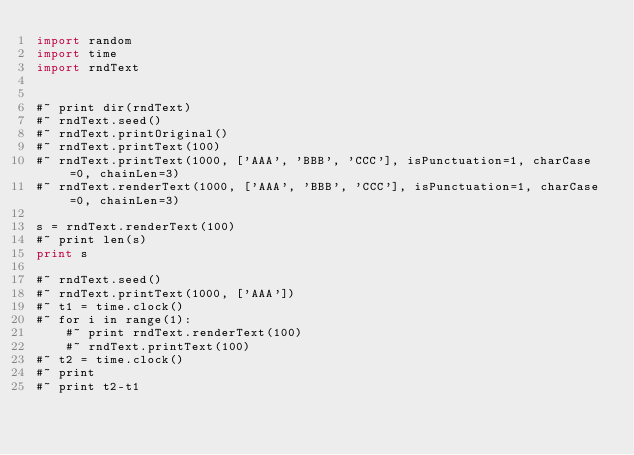<code> <loc_0><loc_0><loc_500><loc_500><_Python_>import random
import time
import rndText


#~ print dir(rndText)
#~ rndText.seed()
#~ rndText.printOriginal()
#~ rndText.printText(100)
#~ rndText.printText(1000, ['AAA', 'BBB', 'CCC'], isPunctuation=1, charCase=0, chainLen=3)
#~ rndText.renderText(1000, ['AAA', 'BBB', 'CCC'], isPunctuation=1, charCase=0, chainLen=3)

s = rndText.renderText(100)
#~ print len(s)
print s

#~ rndText.seed()
#~ rndText.printText(1000, ['AAA'])
#~ t1 = time.clock()
#~ for i in range(1):
    #~ print rndText.renderText(100)
    #~ rndText.printText(100)
#~ t2 = time.clock()
#~ print
#~ print t2-t1

</code> 